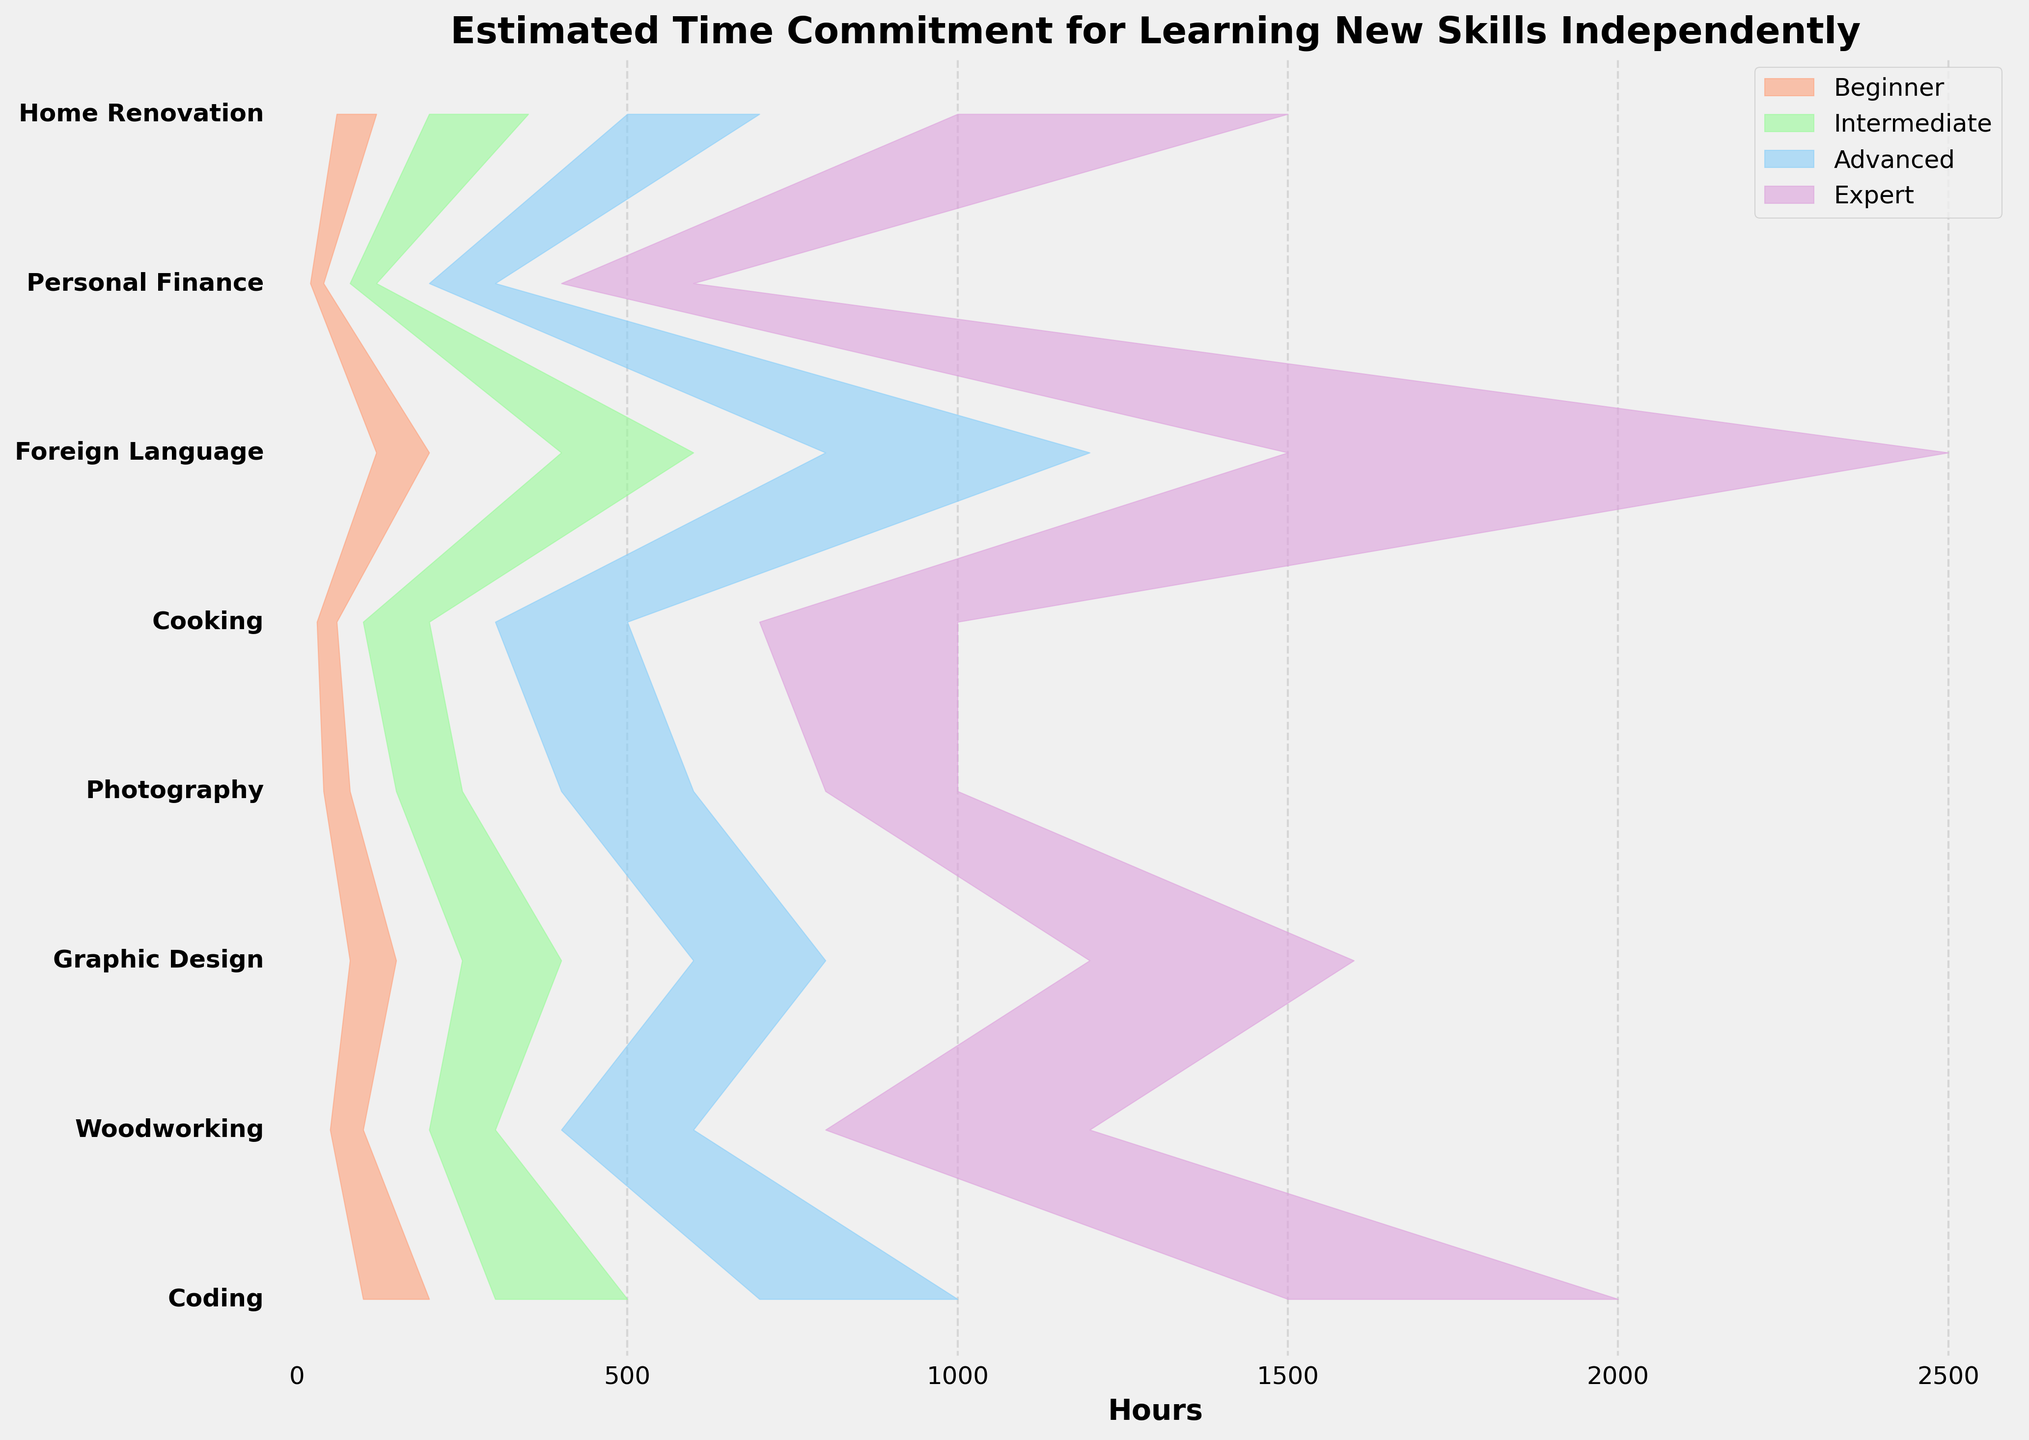Which skill requires the most time to reach the Expert level? By looking at the data, compare the maximum hour range for the Expert level of each skill. The skill with the highest maximum is the one requiring the most time. Foreign Language has a range of 1500-2500 hours, which is the highest.
Answer: Foreign Language What is the range of hours needed for an Advanced level in Cooking? Locate Cooking in the plot and identify the lower and upper bounds of the Advanced level range. Cooking's Advanced level shows a range of 300-500 hours.
Answer: 300-500 Which skills have the smallest and largest time range for reaching the Beginner level? For the Beginner level of each skill, calculate the difference between the upper and lower range values. Personal Finance has the smallest range (20), and Coding has the largest range (100).
Answer: Personal Finance (smallest), Coding (largest) How much more time is required to learn Graphic Design at the Expert level compared to the Intermediate level? Identify the upper bound of the Intermediate range and the minimum bound of the Expert range for Graphic Design, then subtract the Intermediate level's upper bound from the Expert level's lower bound: 1200 - 400 = 800 hours.
Answer: 800 hours What is the average maximum time required for an Advanced level across all skills? Sum the upper bounds of the Advanced range for all the skills, then divide by the number of skills: (1000 + 600 + 800 + 600 + 500 + 1200 + 300 + 700) / 8 = 5700 / 8 = 712.5 hours.
Answer: 712.5 hours Which skill requires more time to reach the Intermediate level, Coding or Foreign Language? Compare the upper bounds of the Intermediate ranges for both skills. Coding reaches up to 500 hours, and Foreign Language goes up to 600 hours.
Answer: Foreign Language What is the total range of hours needed for learning Home Renovation from Beginner to Expert? Sum the lower bound of the Beginner range and the upper bound of the Expert range for Home Renovation: 60 (Beginner) + 1500 (Expert) = 1560 hours.
Answer: 1560 hours Is there a skill that requires over 1000 hours to reach the Advanced level? Check the Advanced ranges for all skills to see if any have an upper bound over 1000 hours. No skill has an Advanced upper bound exceeding 1000 hours; the highest is Foreign Language at 1200 hours.
Answer: No Which skill has the narrowest time range for reaching the Intermediate level? Calculate the range (upper bound - lower bound) for the Intermediate level of each skill. Personal Finance has the narrowest range (120 - 80 = 40 hours).
Answer: Personal Finance What is the difference in the minimum time required to reach the Expert level between Woodworking and Photography? Subtract the lower bound of the Expert range for Photography from that of Woodworking: 800 (Woodworking) - 800 (Photography) = 0 hours.
Answer: 0 hours 